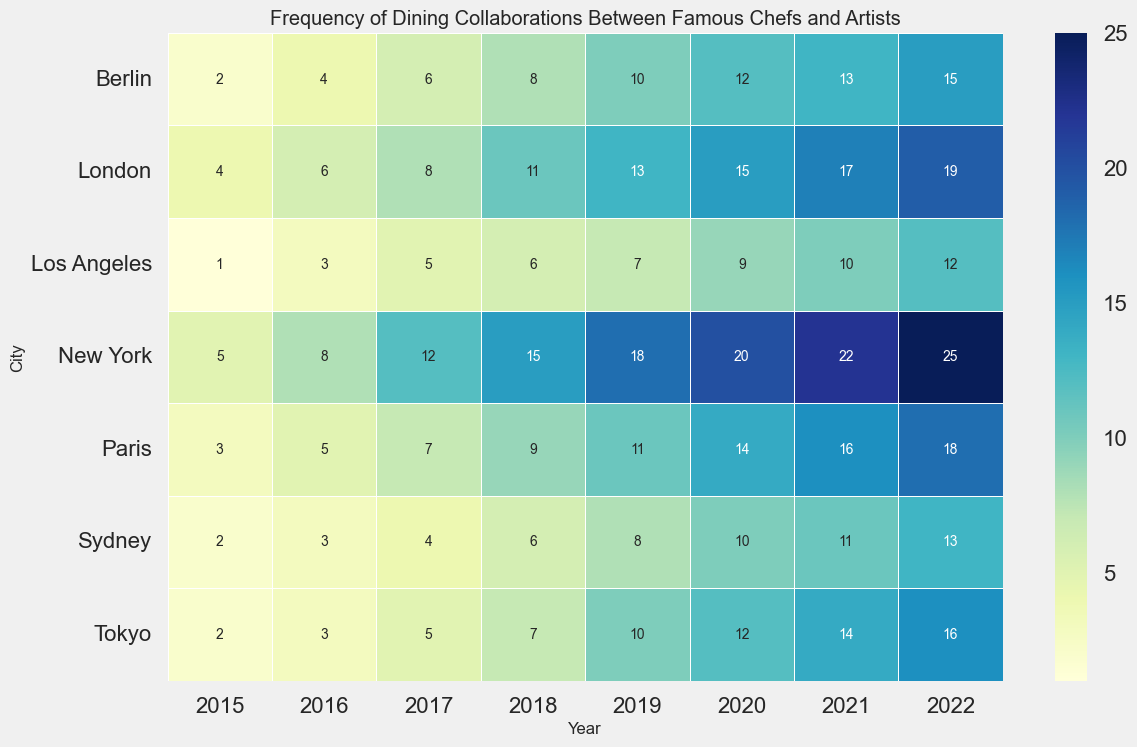what is the city with the highest frequency of dining collaborations in 2022? Locate the year 2022 column and scan down to see that New York has the highest frequency of 25 dining collaborations.
Answer: New York What is the difference in the frequency of collaborations between Tokyo and Sydney in 2020? In the 2020 column, Tokyo has a frequency of 12 and Sydney has a frequency of 10. Subtract 10 from 12 to find the difference.
Answer: 2 Which city showed the largest increase in collaborations from 2015 to 2022? Compare the differences between the 2015 and 2022 values for each city. New York increased from 5 to 25, a difference of 20, which is the largest increase.
Answer: New York Between Paris and Berlin, which city had more dining collaborations in 2019? In the 2019 column, Paris has a frequency of 11 and Berlin has a frequency of 10, making Paris have more collaborations.
Answer: Paris What is the average frequency of dining collaborations for New York over the years? Add the frequencies for New York from 2015 to 2022 (5+8+12+15+18+20+22+25 = 125) and then divide by the number of years (8).
Answer: 15.625 Which year had the lowest frequency of collaborations in Los Angeles? Scan through the Los Angeles row to identify that 2015 had the lowest frequency with a value of 1.
Answer: 2015 By how much did the frequency of collaborations in London change from 2016 to 2018? In the London row, the frequency went from 6 in 2016 to 11 in 2018. The difference is 11 - 6.
Answer: 5 Is the frequency of dining collaborations generally increasing, decreasing, or staying constant over the years for all the cities? Most cities show an increasing trend over the years. For example, New York, Paris, London, Tokyo, Los Angeles, Berlin, and Sydney all show increases.
Answer: Increasing Are there any years where all cities had an increase in frequency compared to the previous year? Check each year and compare it with the previous year for all cities. For instance, from 2017 to 2018, all cities show an increase.
Answer: Yes, 2018 